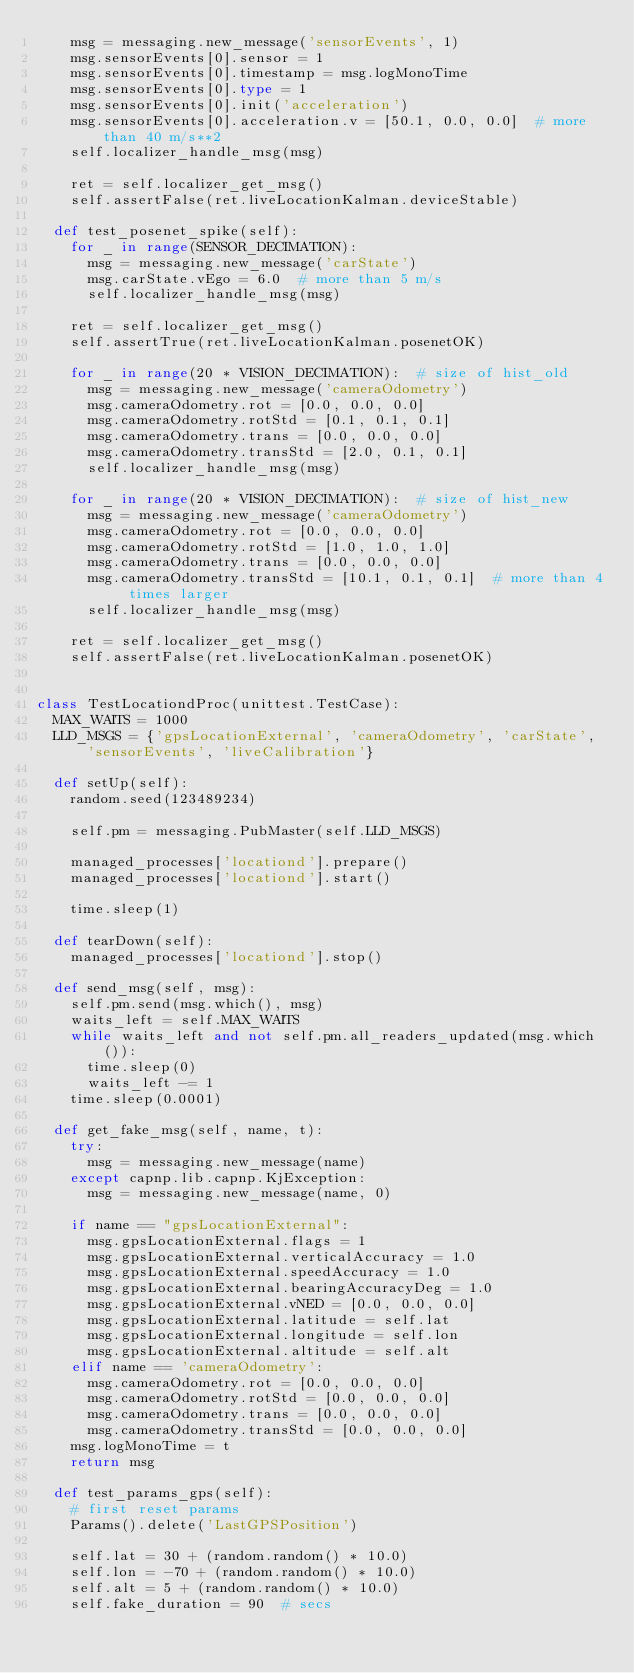<code> <loc_0><loc_0><loc_500><loc_500><_Python_>    msg = messaging.new_message('sensorEvents', 1)
    msg.sensorEvents[0].sensor = 1
    msg.sensorEvents[0].timestamp = msg.logMonoTime
    msg.sensorEvents[0].type = 1
    msg.sensorEvents[0].init('acceleration')
    msg.sensorEvents[0].acceleration.v = [50.1, 0.0, 0.0]  # more than 40 m/s**2
    self.localizer_handle_msg(msg)

    ret = self.localizer_get_msg()
    self.assertFalse(ret.liveLocationKalman.deviceStable)

  def test_posenet_spike(self):
    for _ in range(SENSOR_DECIMATION):
      msg = messaging.new_message('carState')
      msg.carState.vEgo = 6.0  # more than 5 m/s
      self.localizer_handle_msg(msg)

    ret = self.localizer_get_msg()
    self.assertTrue(ret.liveLocationKalman.posenetOK)

    for _ in range(20 * VISION_DECIMATION):  # size of hist_old
      msg = messaging.new_message('cameraOdometry')
      msg.cameraOdometry.rot = [0.0, 0.0, 0.0]
      msg.cameraOdometry.rotStd = [0.1, 0.1, 0.1]
      msg.cameraOdometry.trans = [0.0, 0.0, 0.0]
      msg.cameraOdometry.transStd = [2.0, 0.1, 0.1]
      self.localizer_handle_msg(msg)

    for _ in range(20 * VISION_DECIMATION):  # size of hist_new
      msg = messaging.new_message('cameraOdometry')
      msg.cameraOdometry.rot = [0.0, 0.0, 0.0]
      msg.cameraOdometry.rotStd = [1.0, 1.0, 1.0]
      msg.cameraOdometry.trans = [0.0, 0.0, 0.0]
      msg.cameraOdometry.transStd = [10.1, 0.1, 0.1]  # more than 4 times larger
      self.localizer_handle_msg(msg)

    ret = self.localizer_get_msg()
    self.assertFalse(ret.liveLocationKalman.posenetOK)


class TestLocationdProc(unittest.TestCase):
  MAX_WAITS = 1000
  LLD_MSGS = {'gpsLocationExternal', 'cameraOdometry', 'carState', 'sensorEvents', 'liveCalibration'}

  def setUp(self):
    random.seed(123489234)

    self.pm = messaging.PubMaster(self.LLD_MSGS)

    managed_processes['locationd'].prepare()
    managed_processes['locationd'].start()

    time.sleep(1)

  def tearDown(self):
    managed_processes['locationd'].stop()

  def send_msg(self, msg):
    self.pm.send(msg.which(), msg)
    waits_left = self.MAX_WAITS
    while waits_left and not self.pm.all_readers_updated(msg.which()):
      time.sleep(0)
      waits_left -= 1
    time.sleep(0.0001)

  def get_fake_msg(self, name, t):
    try:
      msg = messaging.new_message(name)
    except capnp.lib.capnp.KjException:
      msg = messaging.new_message(name, 0)

    if name == "gpsLocationExternal":
      msg.gpsLocationExternal.flags = 1
      msg.gpsLocationExternal.verticalAccuracy = 1.0
      msg.gpsLocationExternal.speedAccuracy = 1.0
      msg.gpsLocationExternal.bearingAccuracyDeg = 1.0
      msg.gpsLocationExternal.vNED = [0.0, 0.0, 0.0]
      msg.gpsLocationExternal.latitude = self.lat
      msg.gpsLocationExternal.longitude = self.lon
      msg.gpsLocationExternal.altitude = self.alt
    elif name == 'cameraOdometry':
      msg.cameraOdometry.rot = [0.0, 0.0, 0.0]
      msg.cameraOdometry.rotStd = [0.0, 0.0, 0.0]
      msg.cameraOdometry.trans = [0.0, 0.0, 0.0]
      msg.cameraOdometry.transStd = [0.0, 0.0, 0.0]
    msg.logMonoTime = t
    return msg

  def test_params_gps(self):
    # first reset params
    Params().delete('LastGPSPosition')

    self.lat = 30 + (random.random() * 10.0)
    self.lon = -70 + (random.random() * 10.0)
    self.alt = 5 + (random.random() * 10.0)
    self.fake_duration = 90  # secs</code> 